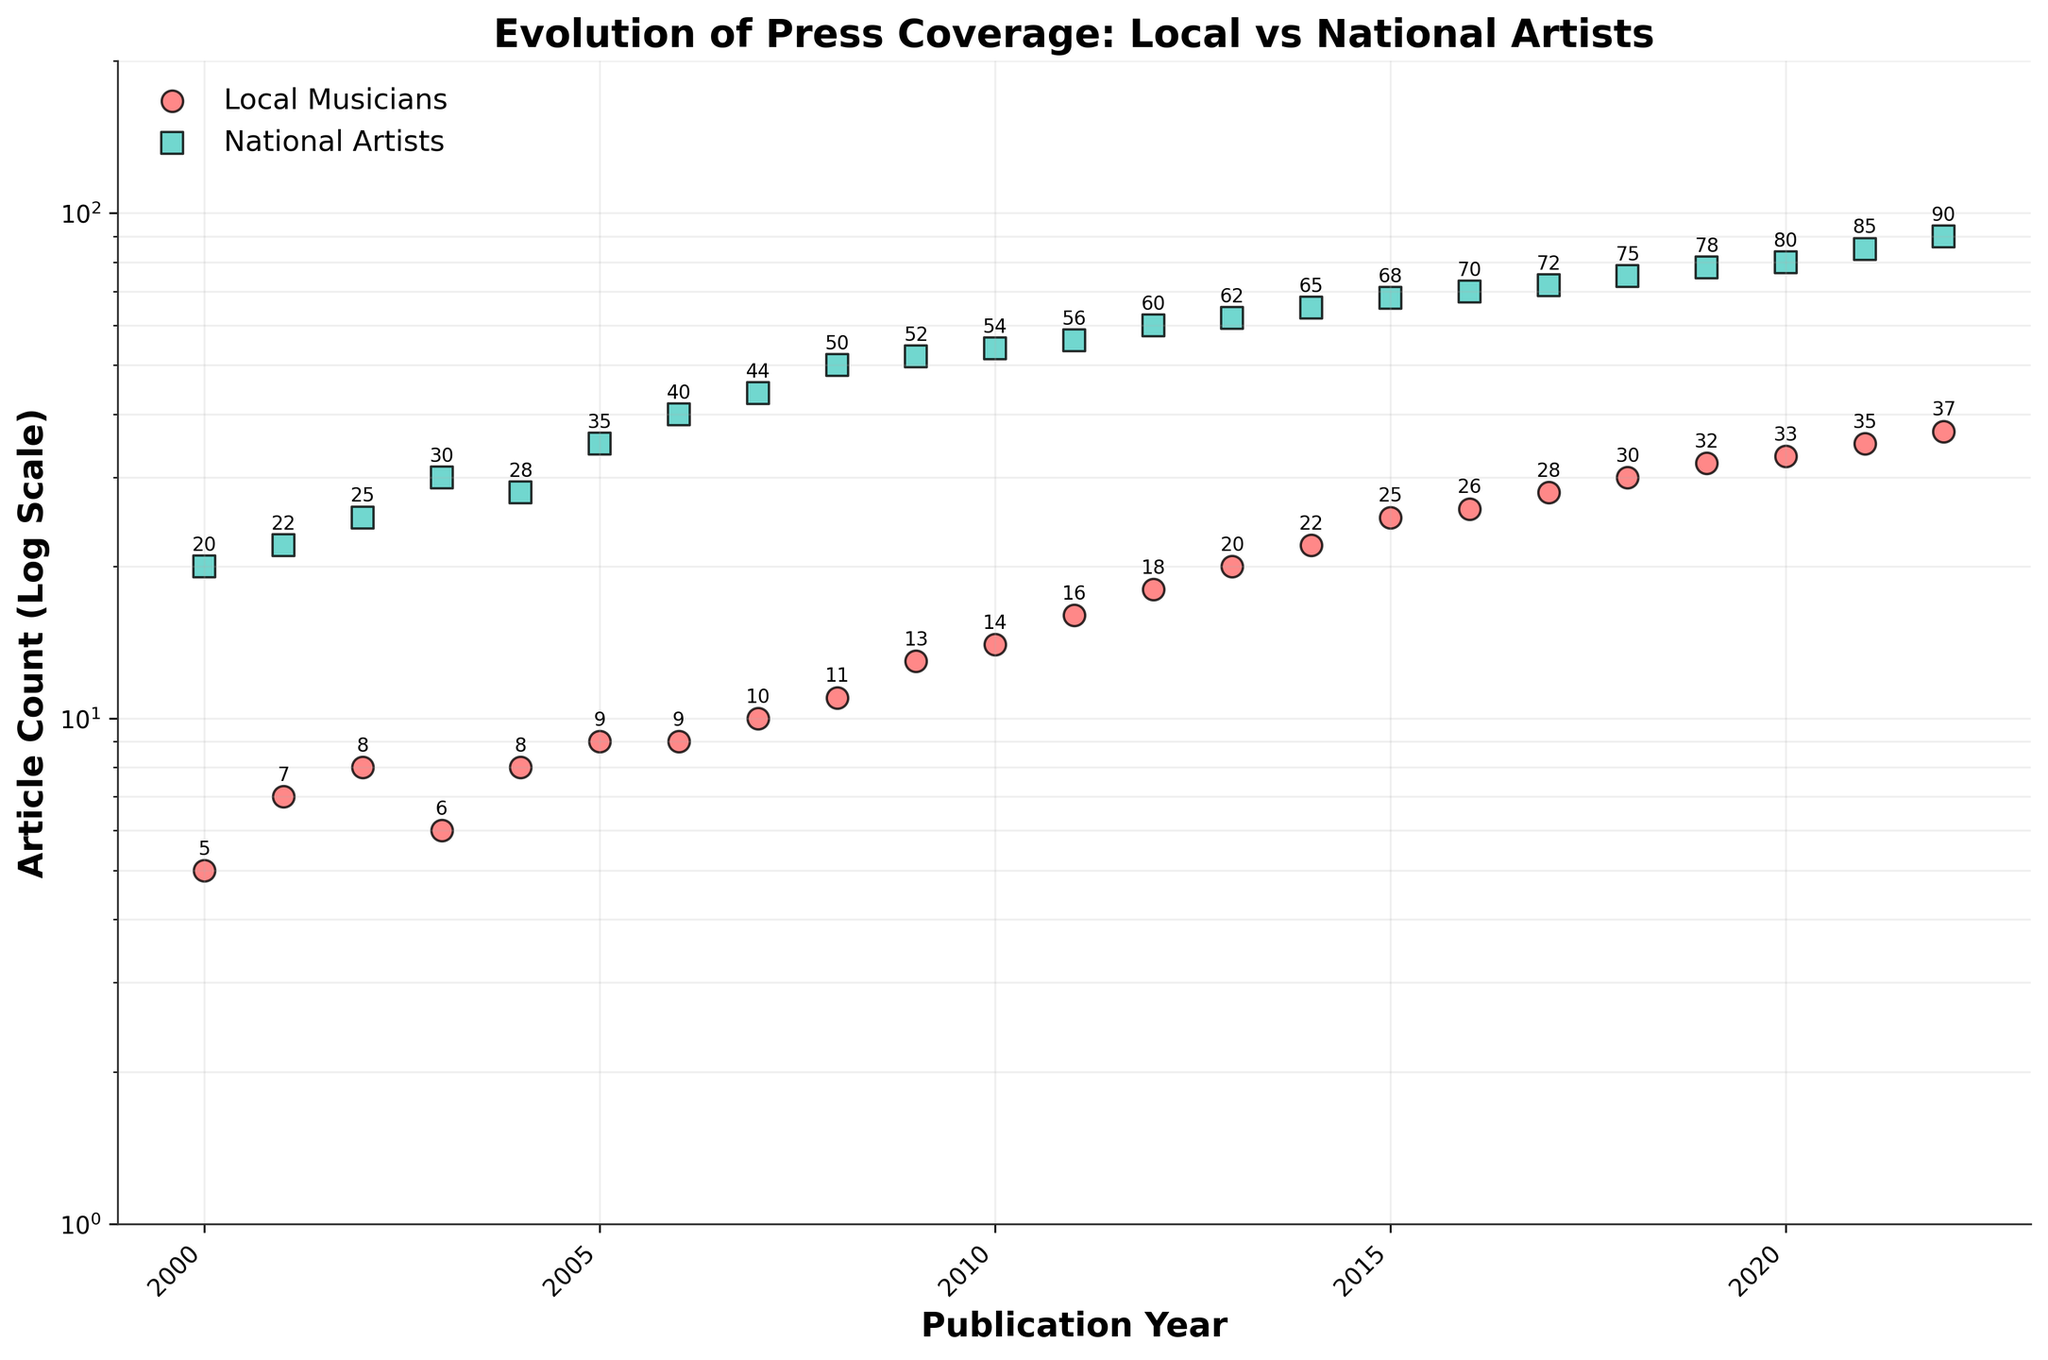what is the title of the figure? The title is usually found at the top of the figure. In this case, it's "Evolution of Press Coverage: Local vs National Artists".
Answer: Evolution of Press Coverage: Local vs National Artists How many data points are there for local musicians? Individual data points can be counted by looking at the plot. There is one data point for each year from 2000 to 2022.
Answer: 23 What color represents local musicians in the scatter plot? The color of data points for local musicians can be identified by looking at the legend. The local musicians' data points are red with black edges.
Answer: Red In which year did the article count for local musicians first reach 20? By scanning the scatter plot's data points for local musicians and referencing the annotation, the year can be determined.
Answer: 2013 What is the trend in the article count for national artists from 2000 to 2022? By observing the scatter plot, we see an upward trajectory in the data points for national artists from 2000 to 2022.
Answer: Increasing Which year had the smallest increase in press coverage for local musicians? By comparing the differences in article counts year over year for local musicians, the smallest increase can be observed.
Answer: 2005 to 2006 Compare the article counts for local musicians and national artists in 2015. What can you observe? By comparing the y-values at the x-coordinate of 2015, the data points for local musicians and national artists can be seen. Local musicians had 25 articles, and national artists had 68.
Answer: National artists had more coverage than local musicians How did the log scale affect the representation of the article counts over the years? A log scale compresses large ranges, making increases in article counts appear less dramatic. This allows better comparison over time, especially with widely varying counts.
Answer: Compresses differences What would be the approximate linear scale article count for local musicians if they followed a similar trend but started with 10 articles in 2000? Explain the likely trend. If the starting count was 10 in 2000, assuming a similar upward trend, counts would roughly double over the years. Instead of ending at 37 in 2022, it might be around 74, exhibiting a proportional increase over the years.
Answer: Approximately 74 